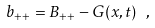<formula> <loc_0><loc_0><loc_500><loc_500>b _ { + + } = B _ { + + } - G ( x , t ) \ ,</formula> 